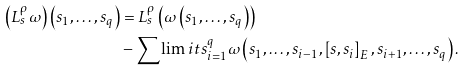<formula> <loc_0><loc_0><loc_500><loc_500>\left ( L _ { s } ^ { \rho } \omega \right ) \left ( s _ { 1 } , \dots , s _ { q } \right ) & = L _ { s } ^ { \rho } \left ( \omega \left ( s _ { 1 } , \dots , s _ { q } \right ) \right ) \\ & - { \sum \lim i t s _ { i = 1 } ^ { q } } \omega \left ( s _ { 1 } , \dots , s _ { i - 1 } , \left [ s , s _ { i } \right ] _ { E } , s _ { i + 1 } , \dots , s _ { q } \right ) .</formula> 